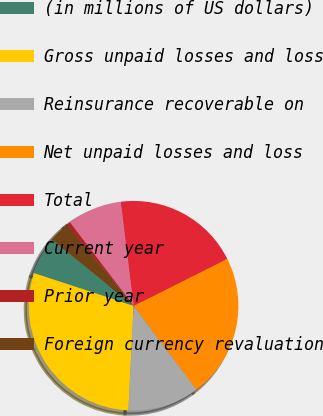Convert chart to OTSL. <chart><loc_0><loc_0><loc_500><loc_500><pie_chart><fcel>(in millions of US dollars)<fcel>Gross unpaid losses and loss<fcel>Reinsurance recoverable on<fcel>Net unpaid losses and loss<fcel>Total<fcel>Current year<fcel>Prior year<fcel>Foreign currency revaluation<nl><fcel>5.81%<fcel>29.26%<fcel>11.03%<fcel>22.16%<fcel>19.55%<fcel>8.42%<fcel>0.58%<fcel>3.2%<nl></chart> 